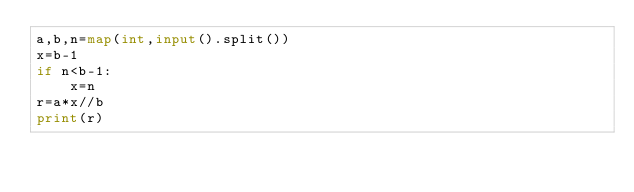Convert code to text. <code><loc_0><loc_0><loc_500><loc_500><_Python_>a,b,n=map(int,input().split())
x=b-1
if n<b-1:
    x=n
r=a*x//b
print(r)
</code> 